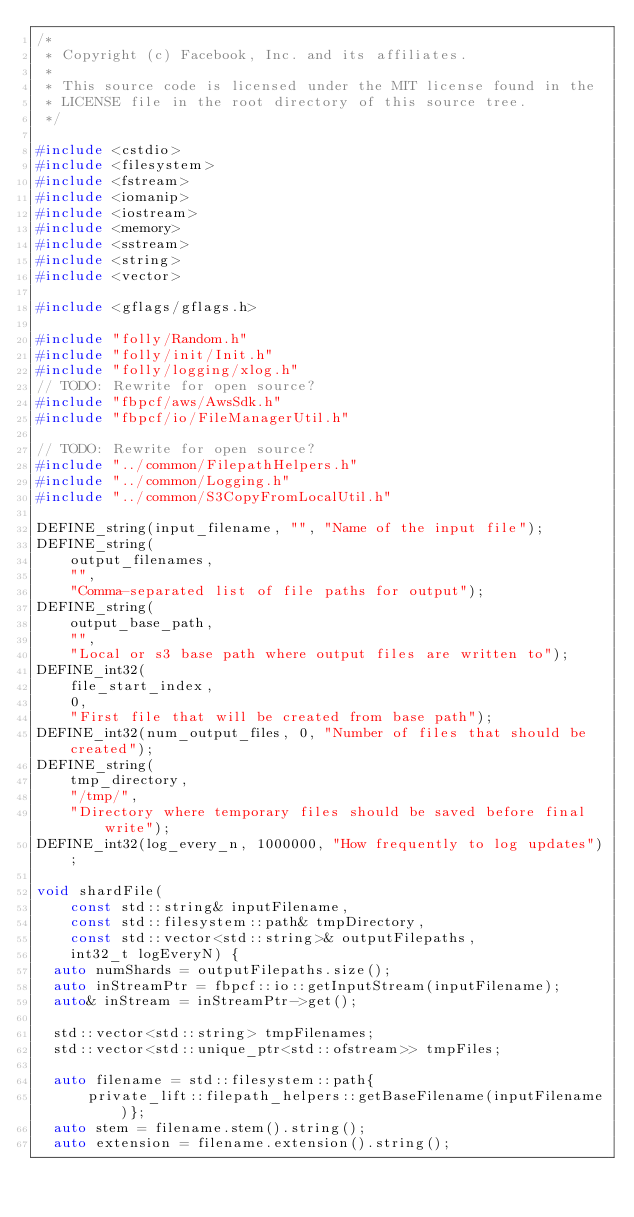<code> <loc_0><loc_0><loc_500><loc_500><_C++_>/*
 * Copyright (c) Facebook, Inc. and its affiliates.
 *
 * This source code is licensed under the MIT license found in the
 * LICENSE file in the root directory of this source tree.
 */

#include <cstdio>
#include <filesystem>
#include <fstream>
#include <iomanip>
#include <iostream>
#include <memory>
#include <sstream>
#include <string>
#include <vector>

#include <gflags/gflags.h>

#include "folly/Random.h"
#include "folly/init/Init.h"
#include "folly/logging/xlog.h"
// TODO: Rewrite for open source?
#include "fbpcf/aws/AwsSdk.h"
#include "fbpcf/io/FileManagerUtil.h"

// TODO: Rewrite for open source?
#include "../common/FilepathHelpers.h"
#include "../common/Logging.h"
#include "../common/S3CopyFromLocalUtil.h"

DEFINE_string(input_filename, "", "Name of the input file");
DEFINE_string(
    output_filenames,
    "",
    "Comma-separated list of file paths for output");
DEFINE_string(
    output_base_path,
    "",
    "Local or s3 base path where output files are written to");
DEFINE_int32(
    file_start_index,
    0,
    "First file that will be created from base path");
DEFINE_int32(num_output_files, 0, "Number of files that should be created");
DEFINE_string(
    tmp_directory,
    "/tmp/",
    "Directory where temporary files should be saved before final write");
DEFINE_int32(log_every_n, 1000000, "How frequently to log updates");

void shardFile(
    const std::string& inputFilename,
    const std::filesystem::path& tmpDirectory,
    const std::vector<std::string>& outputFilepaths,
    int32_t logEveryN) {
  auto numShards = outputFilepaths.size();
  auto inStreamPtr = fbpcf::io::getInputStream(inputFilename);
  auto& inStream = inStreamPtr->get();

  std::vector<std::string> tmpFilenames;
  std::vector<std::unique_ptr<std::ofstream>> tmpFiles;

  auto filename = std::filesystem::path{
      private_lift::filepath_helpers::getBaseFilename(inputFilename)};
  auto stem = filename.stem().string();
  auto extension = filename.extension().string();</code> 